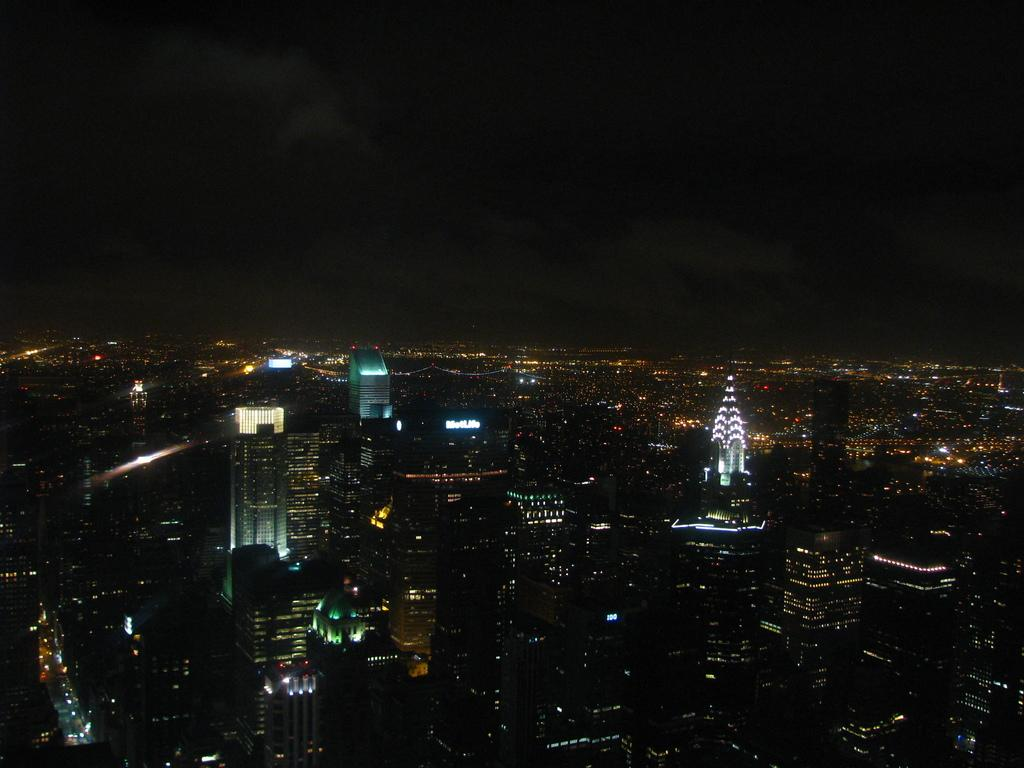What is the overall lighting condition in the image? The image is dark. Despite the darkness, what can be seen in the buildings? There are lights visible in the buildings. What type of legal advice is being sought in the image? There is no indication of any legal advice or lawyer in the image; it only shows lights in buildings. 